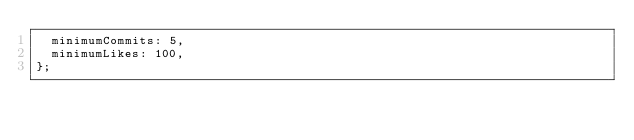Convert code to text. <code><loc_0><loc_0><loc_500><loc_500><_TypeScript_>  minimumCommits: 5,
  minimumLikes: 100,
};
</code> 